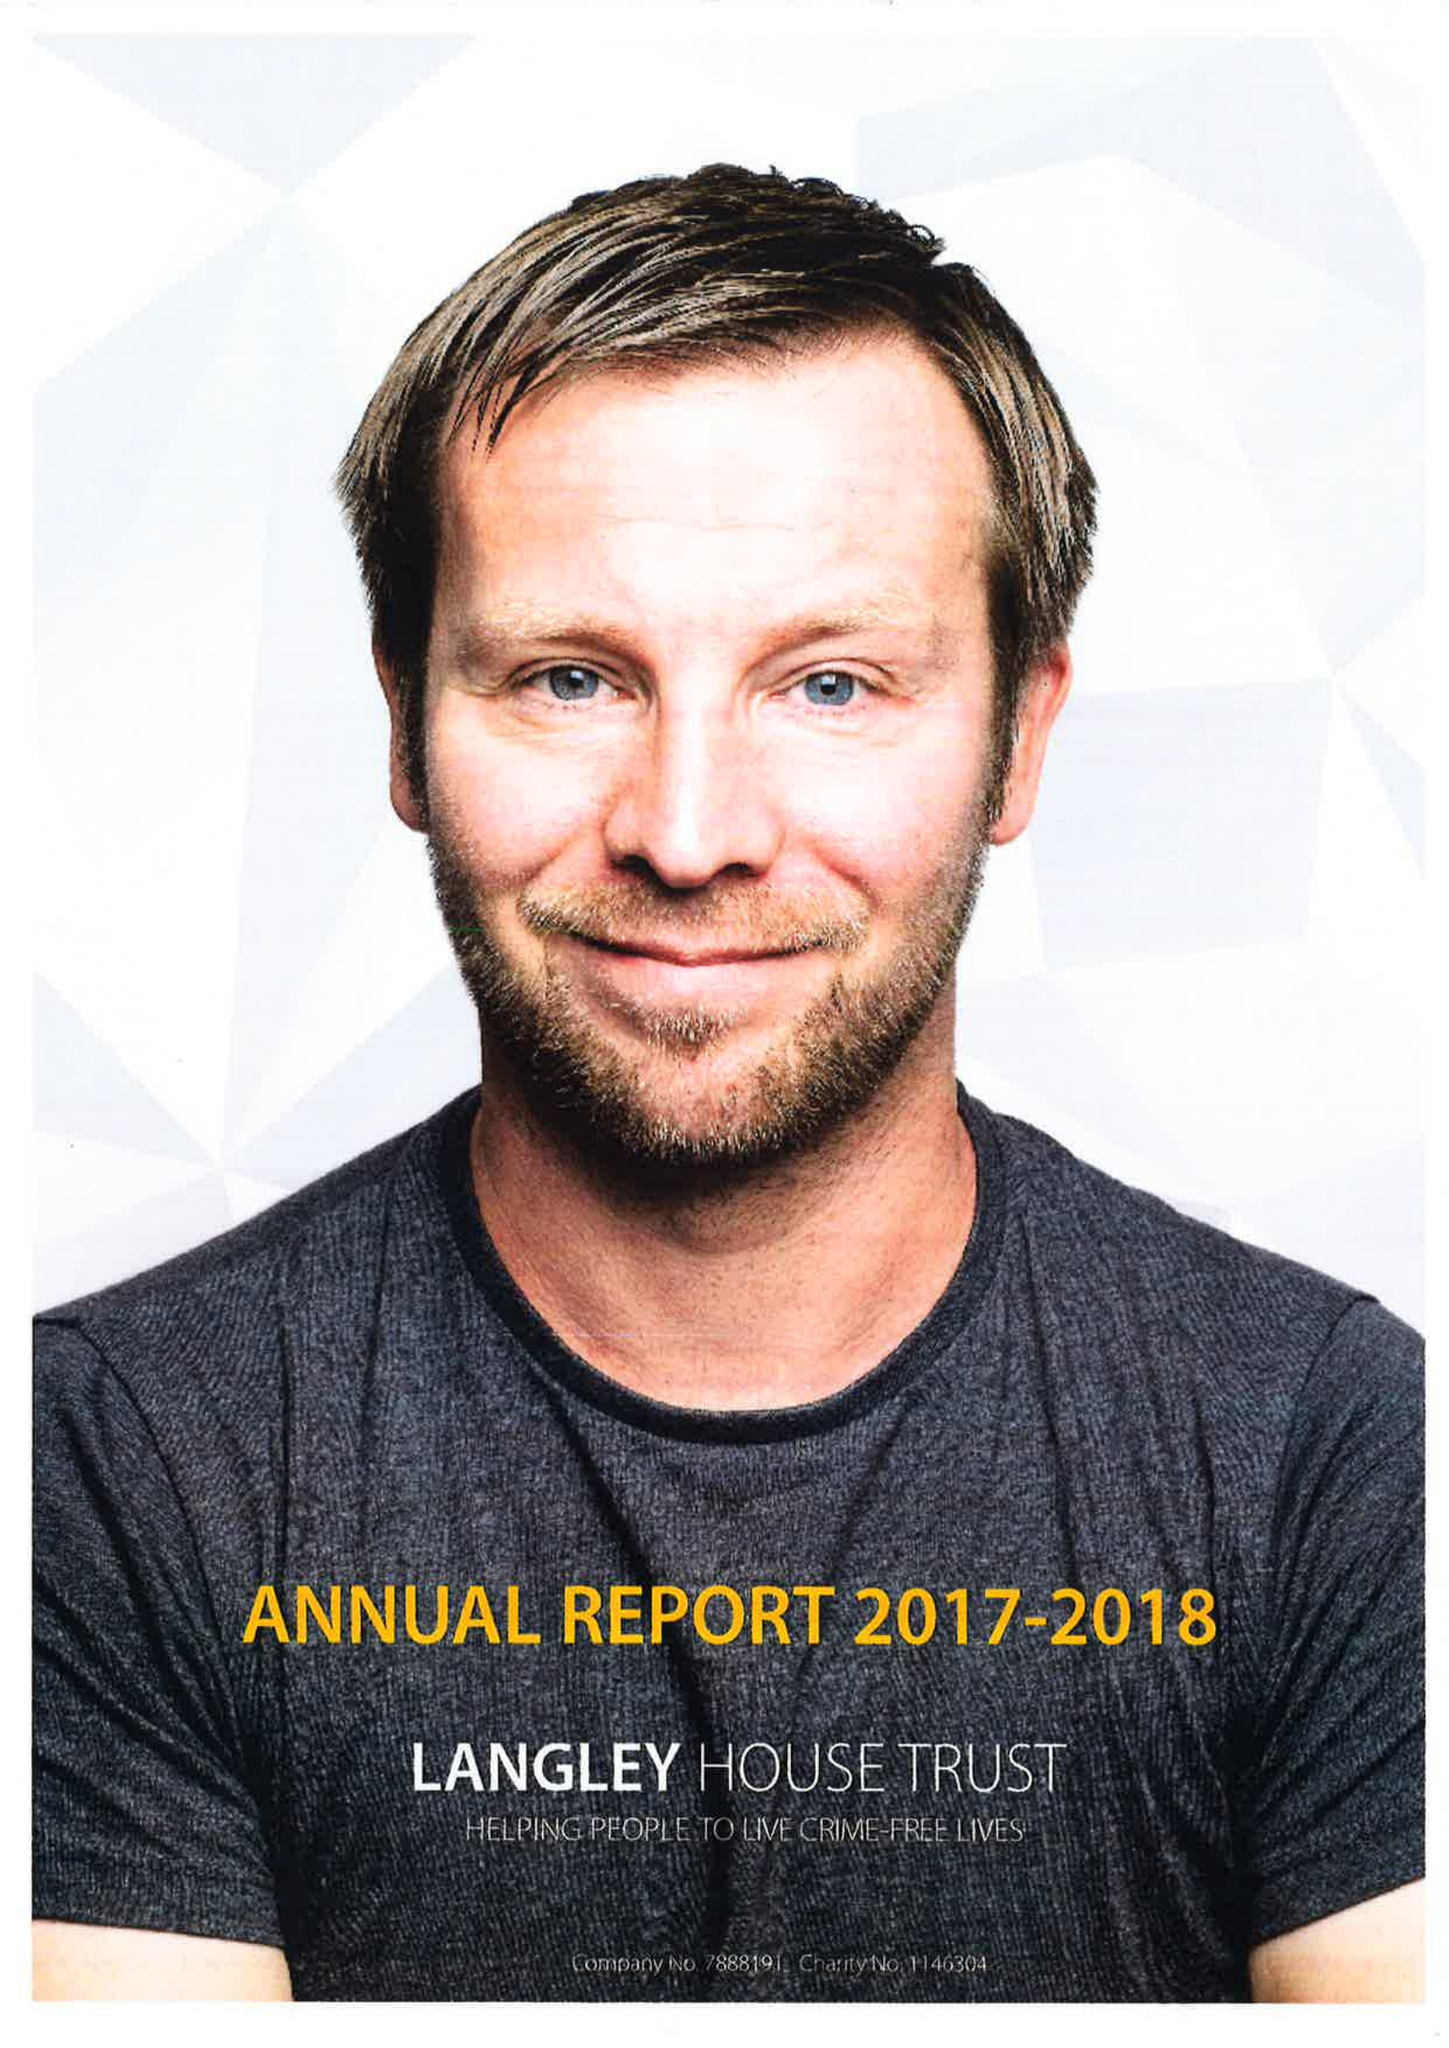What is the value for the spending_annually_in_british_pounds?
Answer the question using a single word or phrase. 12298000.00 